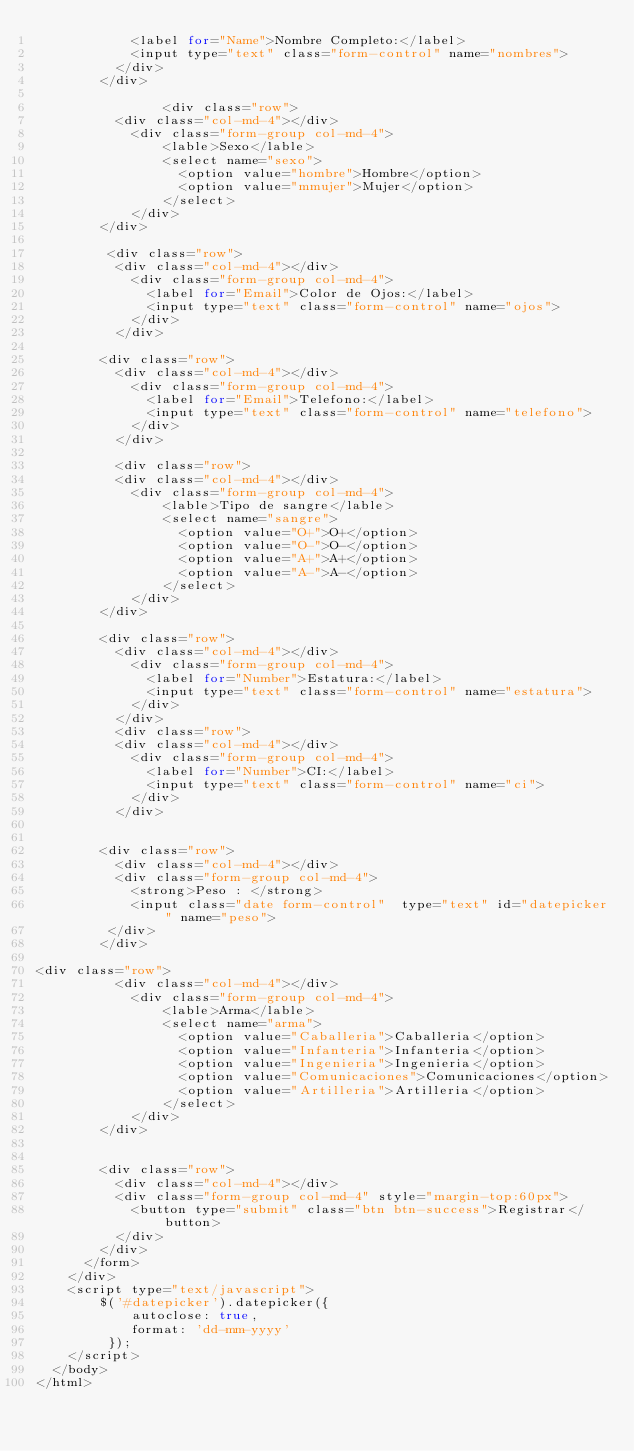<code> <loc_0><loc_0><loc_500><loc_500><_PHP_>            <label for="Name">Nombre Completo:</label>
            <input type="text" class="form-control" name="nombres">
          </div>
        </div>

                <div class="row">
          <div class="col-md-4"></div>
            <div class="form-group col-md-4">
                <lable>Sexo</lable>
                <select name="sexo">
                  <option value="hombre">Hombre</option>
                  <option value="mmujer">Mujer</option>  
                </select>
            </div>
        </div>

         <div class="row">
          <div class="col-md-4"></div>
            <div class="form-group col-md-4">
              <label for="Email">Color de Ojos:</label>
              <input type="text" class="form-control" name="ojos">
            </div>
          </div>

        <div class="row">
          <div class="col-md-4"></div>
            <div class="form-group col-md-4">
              <label for="Email">Telefono:</label>
              <input type="text" class="form-control" name="telefono">
            </div>
          </div>

          <div class="row">
          <div class="col-md-4"></div>
            <div class="form-group col-md-4">
                <lable>Tipo de sangre</lable>
                <select name="sangre">
                  <option value="O+">O+</option>
                  <option value="O-">O-</option>
                  <option value="A+">A+</option>  
                  <option value="A-">A-</option>  
                </select>
            </div>
        </div>

        <div class="row">
          <div class="col-md-4"></div>
            <div class="form-group col-md-4">
              <label for="Number">Estatura:</label>
              <input type="text" class="form-control" name="estatura">
            </div>
          </div>
          <div class="row">
          <div class="col-md-4"></div>
            <div class="form-group col-md-4">
              <label for="Number">CI:</label>
              <input type="text" class="form-control" name="ci">
            </div>
          </div>
        
       
        <div class="row">
          <div class="col-md-4"></div>
          <div class="form-group col-md-4">
            <strong>Peso : </strong>  
            <input class="date form-control"  type="text" id="datepicker" name="peso">   
         </div>
        </div>

<div class="row">
          <div class="col-md-4"></div>
            <div class="form-group col-md-4">
                <lable>Arma</lable>
                <select name="arma">
                  <option value="Caballeria">Caballeria</option>
                  <option value="Infanteria">Infanteria</option>
                  <option value="Ingenieria">Ingenieria</option>  
                  <option value="Comunicaciones">Comunicaciones</option>  
                  <option value="Artilleria">Artilleria</option> 
                </select>
            </div>
        </div>

         
        <div class="row">
          <div class="col-md-4"></div>
          <div class="form-group col-md-4" style="margin-top:60px">
            <button type="submit" class="btn btn-success">Registrar</button>
          </div>
        </div>
      </form>
    </div>
    <script type="text/javascript">  
        $('#datepicker').datepicker({ 
            autoclose: true,   
            format: 'dd-mm-yyyy'  
         });  
    </script>
  </body>
</html></code> 